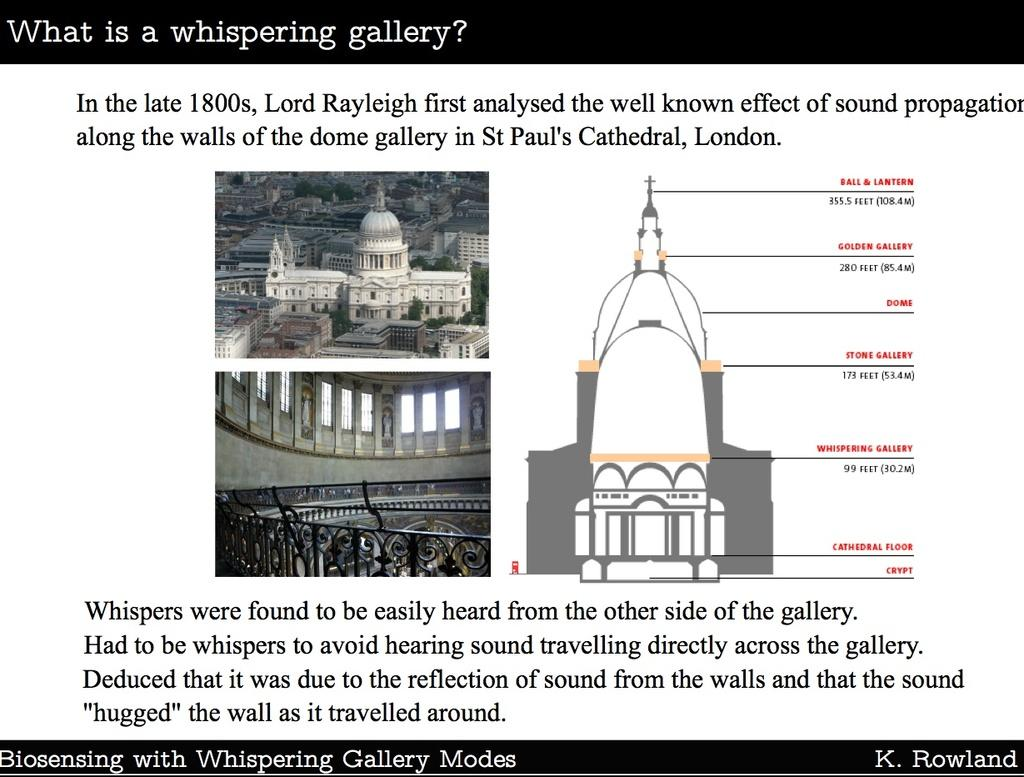<image>
Create a compact narrative representing the image presented. A screen with a question at the top that asks "What is a whispering gallery?" 